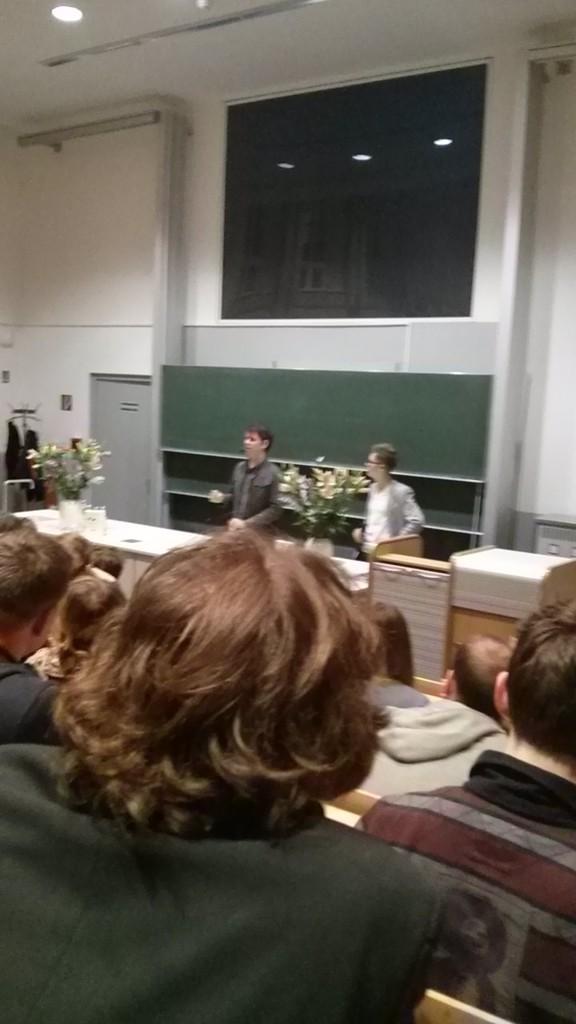In one or two sentences, can you explain what this image depicts? There are two persons standing and there is a table in front of them which has flower vases and some other objects on it and there are few people sitting in front of them. 